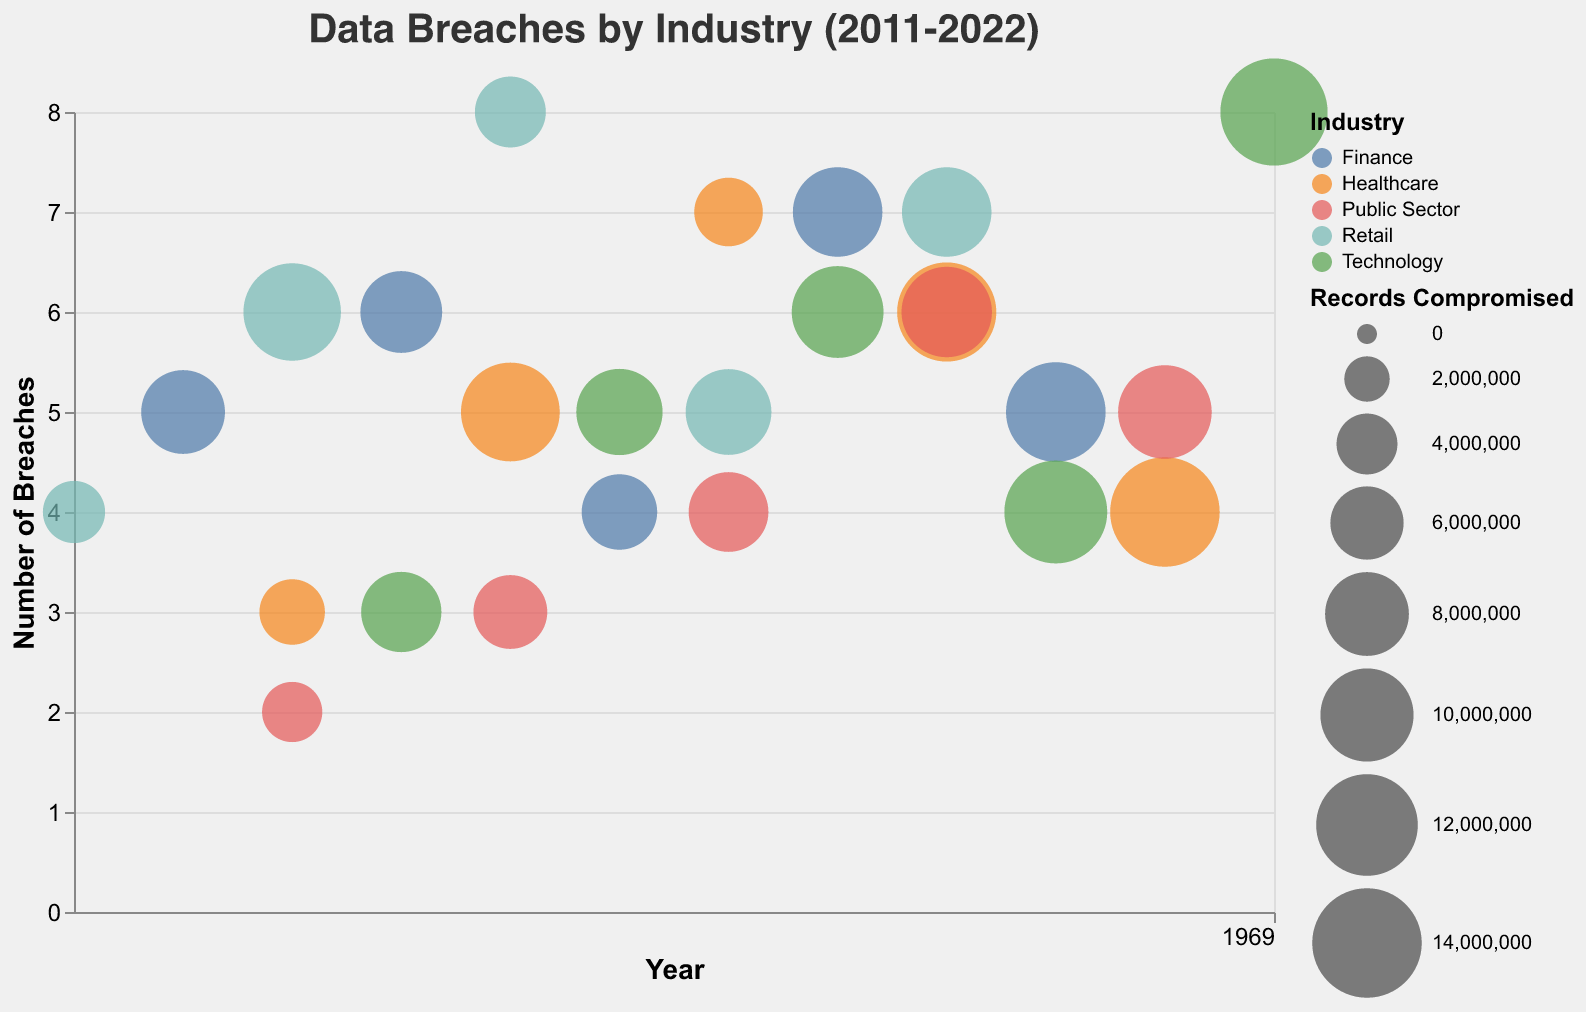What is the title of the chart? The title is displayed at the top of the chart. It states "Data Breaches by Industry (2011-2022)".
Answer: Data Breaches by Industry (2011-2022) Which industry had the highest number of records compromised in a single year? To determine this, we need to compare the largest bubble sizes for each industry across all years. The largest bubble appears in Healthcare in 2021 with 14,000,000 records compromised.
Answer: Healthcare in 2021 How many breaches did the Finance industry have in 2018? Locate the Finance industry on the y-axis and find the respective year on the x-axis. For 2018, the chart shows 7 breaches.
Answer: 7 What was the number of records compromised in the Technology industry in 2022? Identify the bubble for Technology in the year 2022 and refer to its size in the legend. It indicates 13,400,000 records were compromised.
Answer: 13,400,000 Which two years saw the highest number of breaches in Retail? Inspect the Retail bubbles on the y-axis and note the height of the points corresponding to the years. The years with the highest number of breaches (8) in Retail are 2015 and 2019.
Answer: 2015 and 2019 Compare the number of breaches in Healthcare between 2015 and 2017. Which year had more? Find the Healthcare data points for the years 2015 and 2017 on the y-axis. In 2017, the number of breaches (7) was more than in 2015 (5).
Answer: 2017 What trend do we observe in the number of breaches in the Public Sector from 2013 to 2021? Examine the Public Sector bubbles from 2013 to 2021. The number of breaches increased from 2 in 2013, peaked at 2019 with 6, and slightly decreased to 5 in 2021.
Answer: Increasing initially, then a slight decrease What is the total number of records compromised in the Retail industry from 2011 to 2019? Sum the number of records compromised in Retail for all relevant years: 4,200,000 (2011) + 11,000,000 (2013) + 5,600,000 (2015) + 8,400,000 (2017) + 9,200,000 (2019) equals to 38,400,000.
Answer: 38,400,000 Which industry had the consistent trend in the number of breaches over the decade? By observing the chart, the Technology industry shows a relatively steady increase in the number of breaches over the decade.
Answer: Technology In which year did Healthcare experience the maximum number of breaches? Check the y-axis values for Healthcare across all years. The highest number appears in 2017 with 7 breaches.
Answer: 2017 